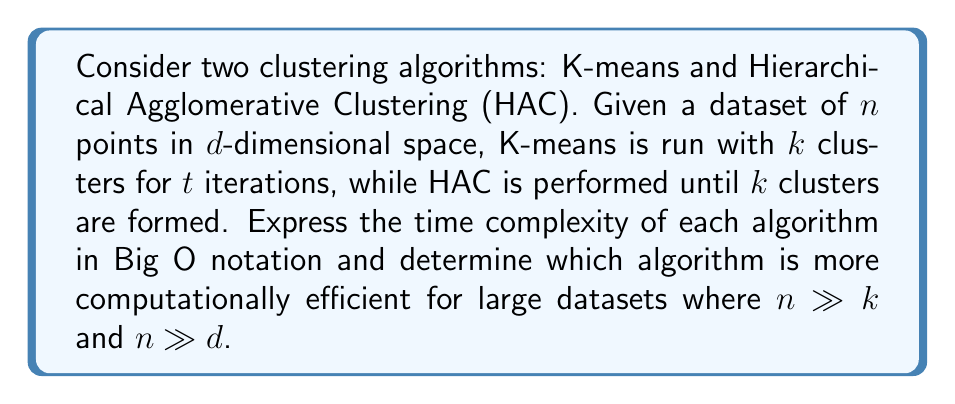Can you solve this math problem? To solve this problem, we need to analyze the time complexity of both algorithms:

1. K-means:
   - Each iteration involves assigning $n$ points to $k$ clusters and updating $k$ centroids.
   - Assigning each point requires $O(kd)$ operations (computing distances to $k$ centroids in $d$ dimensions).
   - Updating centroids takes $O(nd)$ operations (summing up points in each cluster).
   - Total complexity per iteration: $O(nkd + nd) = O(nkd)$
   - For $t$ iterations, the overall complexity is $O(nkdt)$

2. Hierarchical Agglomerative Clustering (HAC):
   - Initially, we compute pairwise distances between all $n$ points: $O(n^2d)$
   - The algorithm performs $n-k$ merging steps to reach $k$ clusters.
   - Each step requires finding the closest pair of clusters: $O(n^2)$
   - Updating distances after merging: $O(n)$
   - Total complexity: $O(n^2d + n^3) = O(n^3)$ (since typically $n \gg d$)

Comparing the two:
- K-means: $O(nkdt)$
- HAC: $O(n^3)$

For large datasets where $n \gg k$ and $n \gg d$:
- K-means complexity grows linearly with $n$
- HAC complexity grows cubically with $n$

Therefore, K-means is more computationally efficient for large datasets, as its time complexity grows much slower with respect to $n$ compared to HAC.
Answer: K-means is more computationally efficient for large datasets, with a time complexity of $O(nkdt)$ compared to HAC's $O(n^3)$. 